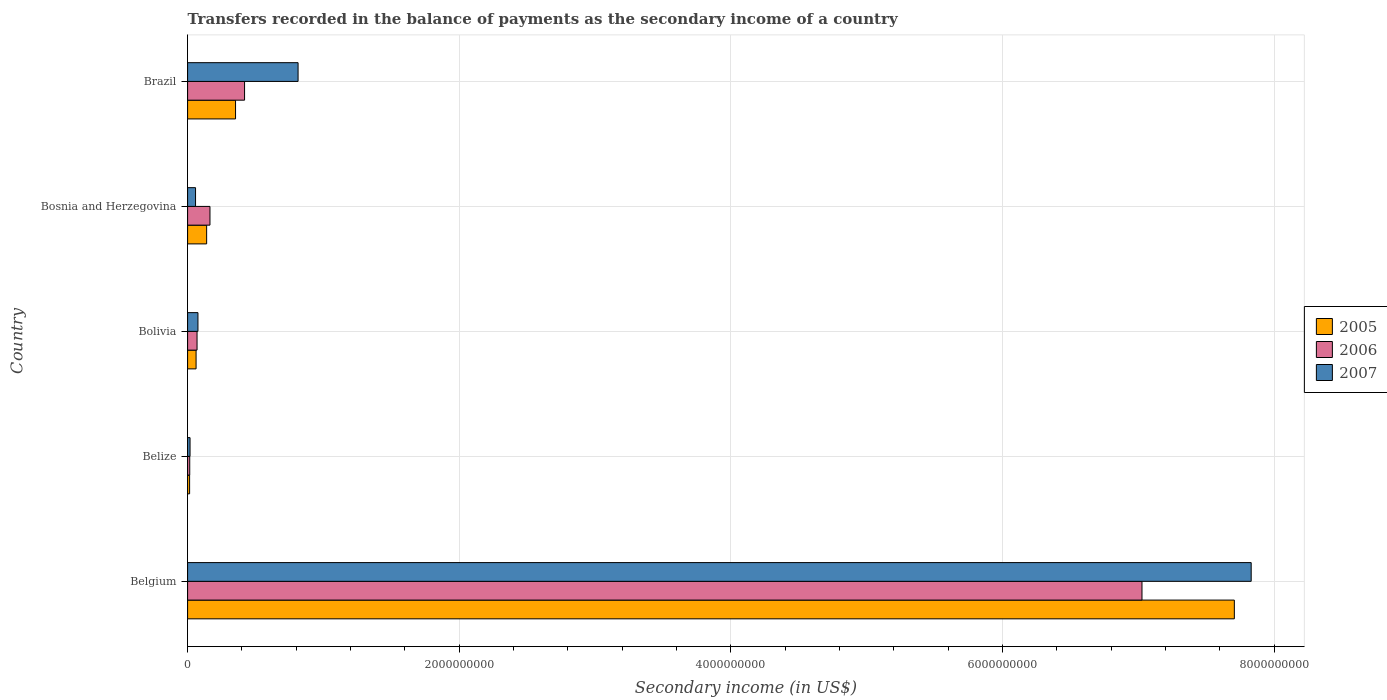How many different coloured bars are there?
Your response must be concise. 3. How many groups of bars are there?
Your answer should be compact. 5. How many bars are there on the 2nd tick from the bottom?
Give a very brief answer. 3. In how many cases, is the number of bars for a given country not equal to the number of legend labels?
Provide a succinct answer. 0. What is the secondary income of in 2006 in Bosnia and Herzegovina?
Your response must be concise. 1.65e+08. Across all countries, what is the maximum secondary income of in 2007?
Provide a succinct answer. 7.83e+09. Across all countries, what is the minimum secondary income of in 2007?
Offer a terse response. 1.80e+07. In which country was the secondary income of in 2006 maximum?
Ensure brevity in your answer.  Belgium. In which country was the secondary income of in 2006 minimum?
Your answer should be very brief. Belize. What is the total secondary income of in 2007 in the graph?
Your answer should be compact. 8.80e+09. What is the difference between the secondary income of in 2006 in Belize and that in Bolivia?
Provide a succinct answer. -5.38e+07. What is the difference between the secondary income of in 2006 in Bolivia and the secondary income of in 2007 in Belgium?
Provide a short and direct response. -7.76e+09. What is the average secondary income of in 2007 per country?
Provide a short and direct response. 1.76e+09. What is the difference between the secondary income of in 2005 and secondary income of in 2006 in Bosnia and Herzegovina?
Offer a very short reply. -2.45e+07. In how many countries, is the secondary income of in 2006 greater than 7200000000 US$?
Your answer should be very brief. 0. What is the ratio of the secondary income of in 2007 in Belize to that in Bosnia and Herzegovina?
Your answer should be very brief. 0.31. What is the difference between the highest and the second highest secondary income of in 2005?
Ensure brevity in your answer.  7.35e+09. What is the difference between the highest and the lowest secondary income of in 2006?
Ensure brevity in your answer.  7.01e+09. What does the 3rd bar from the top in Brazil represents?
Offer a terse response. 2005. Is it the case that in every country, the sum of the secondary income of in 2006 and secondary income of in 2005 is greater than the secondary income of in 2007?
Offer a terse response. No. Are all the bars in the graph horizontal?
Ensure brevity in your answer.  Yes. How many countries are there in the graph?
Offer a terse response. 5. Does the graph contain any zero values?
Give a very brief answer. No. Where does the legend appear in the graph?
Give a very brief answer. Center right. What is the title of the graph?
Provide a short and direct response. Transfers recorded in the balance of payments as the secondary income of a country. Does "1991" appear as one of the legend labels in the graph?
Ensure brevity in your answer.  No. What is the label or title of the X-axis?
Keep it short and to the point. Secondary income (in US$). What is the label or title of the Y-axis?
Ensure brevity in your answer.  Country. What is the Secondary income (in US$) of 2005 in Belgium?
Your answer should be compact. 7.71e+09. What is the Secondary income (in US$) of 2006 in Belgium?
Keep it short and to the point. 7.03e+09. What is the Secondary income (in US$) in 2007 in Belgium?
Offer a very short reply. 7.83e+09. What is the Secondary income (in US$) in 2005 in Belize?
Provide a succinct answer. 1.48e+07. What is the Secondary income (in US$) in 2006 in Belize?
Your answer should be compact. 1.58e+07. What is the Secondary income (in US$) in 2007 in Belize?
Offer a terse response. 1.80e+07. What is the Secondary income (in US$) in 2005 in Bolivia?
Provide a short and direct response. 6.25e+07. What is the Secondary income (in US$) of 2006 in Bolivia?
Your response must be concise. 6.96e+07. What is the Secondary income (in US$) of 2007 in Bolivia?
Your answer should be compact. 7.62e+07. What is the Secondary income (in US$) of 2005 in Bosnia and Herzegovina?
Your answer should be compact. 1.40e+08. What is the Secondary income (in US$) of 2006 in Bosnia and Herzegovina?
Give a very brief answer. 1.65e+08. What is the Secondary income (in US$) in 2007 in Bosnia and Herzegovina?
Give a very brief answer. 5.85e+07. What is the Secondary income (in US$) of 2005 in Brazil?
Give a very brief answer. 3.53e+08. What is the Secondary income (in US$) in 2006 in Brazil?
Your answer should be very brief. 4.19e+08. What is the Secondary income (in US$) in 2007 in Brazil?
Your response must be concise. 8.13e+08. Across all countries, what is the maximum Secondary income (in US$) of 2005?
Provide a succinct answer. 7.71e+09. Across all countries, what is the maximum Secondary income (in US$) in 2006?
Your answer should be compact. 7.03e+09. Across all countries, what is the maximum Secondary income (in US$) of 2007?
Your answer should be compact. 7.83e+09. Across all countries, what is the minimum Secondary income (in US$) of 2005?
Offer a very short reply. 1.48e+07. Across all countries, what is the minimum Secondary income (in US$) in 2006?
Your answer should be very brief. 1.58e+07. Across all countries, what is the minimum Secondary income (in US$) in 2007?
Give a very brief answer. 1.80e+07. What is the total Secondary income (in US$) in 2005 in the graph?
Provide a short and direct response. 8.28e+09. What is the total Secondary income (in US$) of 2006 in the graph?
Your answer should be compact. 7.70e+09. What is the total Secondary income (in US$) of 2007 in the graph?
Provide a succinct answer. 8.80e+09. What is the difference between the Secondary income (in US$) in 2005 in Belgium and that in Belize?
Make the answer very short. 7.69e+09. What is the difference between the Secondary income (in US$) of 2006 in Belgium and that in Belize?
Your answer should be very brief. 7.01e+09. What is the difference between the Secondary income (in US$) of 2007 in Belgium and that in Belize?
Offer a very short reply. 7.81e+09. What is the difference between the Secondary income (in US$) in 2005 in Belgium and that in Bolivia?
Ensure brevity in your answer.  7.64e+09. What is the difference between the Secondary income (in US$) of 2006 in Belgium and that in Bolivia?
Your response must be concise. 6.96e+09. What is the difference between the Secondary income (in US$) of 2007 in Belgium and that in Bolivia?
Your answer should be compact. 7.76e+09. What is the difference between the Secondary income (in US$) in 2005 in Belgium and that in Bosnia and Herzegovina?
Provide a short and direct response. 7.57e+09. What is the difference between the Secondary income (in US$) in 2006 in Belgium and that in Bosnia and Herzegovina?
Your answer should be compact. 6.86e+09. What is the difference between the Secondary income (in US$) of 2007 in Belgium and that in Bosnia and Herzegovina?
Offer a very short reply. 7.77e+09. What is the difference between the Secondary income (in US$) in 2005 in Belgium and that in Brazil?
Offer a terse response. 7.35e+09. What is the difference between the Secondary income (in US$) of 2006 in Belgium and that in Brazil?
Offer a very short reply. 6.61e+09. What is the difference between the Secondary income (in US$) of 2007 in Belgium and that in Brazil?
Provide a succinct answer. 7.02e+09. What is the difference between the Secondary income (in US$) of 2005 in Belize and that in Bolivia?
Keep it short and to the point. -4.77e+07. What is the difference between the Secondary income (in US$) of 2006 in Belize and that in Bolivia?
Keep it short and to the point. -5.38e+07. What is the difference between the Secondary income (in US$) of 2007 in Belize and that in Bolivia?
Your answer should be very brief. -5.82e+07. What is the difference between the Secondary income (in US$) in 2005 in Belize and that in Bosnia and Herzegovina?
Your answer should be compact. -1.25e+08. What is the difference between the Secondary income (in US$) in 2006 in Belize and that in Bosnia and Herzegovina?
Your response must be concise. -1.49e+08. What is the difference between the Secondary income (in US$) of 2007 in Belize and that in Bosnia and Herzegovina?
Make the answer very short. -4.05e+07. What is the difference between the Secondary income (in US$) of 2005 in Belize and that in Brazil?
Your answer should be compact. -3.38e+08. What is the difference between the Secondary income (in US$) of 2006 in Belize and that in Brazil?
Your answer should be very brief. -4.04e+08. What is the difference between the Secondary income (in US$) of 2007 in Belize and that in Brazil?
Offer a terse response. -7.95e+08. What is the difference between the Secondary income (in US$) in 2005 in Bolivia and that in Bosnia and Herzegovina?
Keep it short and to the point. -7.78e+07. What is the difference between the Secondary income (in US$) of 2006 in Bolivia and that in Bosnia and Herzegovina?
Make the answer very short. -9.51e+07. What is the difference between the Secondary income (in US$) in 2007 in Bolivia and that in Bosnia and Herzegovina?
Make the answer very short. 1.77e+07. What is the difference between the Secondary income (in US$) of 2005 in Bolivia and that in Brazil?
Your answer should be very brief. -2.91e+08. What is the difference between the Secondary income (in US$) of 2006 in Bolivia and that in Brazil?
Ensure brevity in your answer.  -3.50e+08. What is the difference between the Secondary income (in US$) in 2007 in Bolivia and that in Brazil?
Your answer should be compact. -7.37e+08. What is the difference between the Secondary income (in US$) in 2005 in Bosnia and Herzegovina and that in Brazil?
Give a very brief answer. -2.13e+08. What is the difference between the Secondary income (in US$) in 2006 in Bosnia and Herzegovina and that in Brazil?
Make the answer very short. -2.55e+08. What is the difference between the Secondary income (in US$) of 2007 in Bosnia and Herzegovina and that in Brazil?
Provide a succinct answer. -7.55e+08. What is the difference between the Secondary income (in US$) in 2005 in Belgium and the Secondary income (in US$) in 2006 in Belize?
Provide a succinct answer. 7.69e+09. What is the difference between the Secondary income (in US$) in 2005 in Belgium and the Secondary income (in US$) in 2007 in Belize?
Offer a terse response. 7.69e+09. What is the difference between the Secondary income (in US$) of 2006 in Belgium and the Secondary income (in US$) of 2007 in Belize?
Give a very brief answer. 7.01e+09. What is the difference between the Secondary income (in US$) of 2005 in Belgium and the Secondary income (in US$) of 2006 in Bolivia?
Your answer should be very brief. 7.64e+09. What is the difference between the Secondary income (in US$) of 2005 in Belgium and the Secondary income (in US$) of 2007 in Bolivia?
Make the answer very short. 7.63e+09. What is the difference between the Secondary income (in US$) of 2006 in Belgium and the Secondary income (in US$) of 2007 in Bolivia?
Offer a very short reply. 6.95e+09. What is the difference between the Secondary income (in US$) in 2005 in Belgium and the Secondary income (in US$) in 2006 in Bosnia and Herzegovina?
Keep it short and to the point. 7.54e+09. What is the difference between the Secondary income (in US$) of 2005 in Belgium and the Secondary income (in US$) of 2007 in Bosnia and Herzegovina?
Your response must be concise. 7.65e+09. What is the difference between the Secondary income (in US$) of 2006 in Belgium and the Secondary income (in US$) of 2007 in Bosnia and Herzegovina?
Give a very brief answer. 6.97e+09. What is the difference between the Secondary income (in US$) of 2005 in Belgium and the Secondary income (in US$) of 2006 in Brazil?
Give a very brief answer. 7.29e+09. What is the difference between the Secondary income (in US$) of 2005 in Belgium and the Secondary income (in US$) of 2007 in Brazil?
Your answer should be very brief. 6.89e+09. What is the difference between the Secondary income (in US$) in 2006 in Belgium and the Secondary income (in US$) in 2007 in Brazil?
Provide a succinct answer. 6.21e+09. What is the difference between the Secondary income (in US$) of 2005 in Belize and the Secondary income (in US$) of 2006 in Bolivia?
Offer a terse response. -5.48e+07. What is the difference between the Secondary income (in US$) in 2005 in Belize and the Secondary income (in US$) in 2007 in Bolivia?
Keep it short and to the point. -6.14e+07. What is the difference between the Secondary income (in US$) of 2006 in Belize and the Secondary income (in US$) of 2007 in Bolivia?
Make the answer very short. -6.05e+07. What is the difference between the Secondary income (in US$) of 2005 in Belize and the Secondary income (in US$) of 2006 in Bosnia and Herzegovina?
Ensure brevity in your answer.  -1.50e+08. What is the difference between the Secondary income (in US$) of 2005 in Belize and the Secondary income (in US$) of 2007 in Bosnia and Herzegovina?
Your answer should be compact. -4.37e+07. What is the difference between the Secondary income (in US$) of 2006 in Belize and the Secondary income (in US$) of 2007 in Bosnia and Herzegovina?
Provide a succinct answer. -4.28e+07. What is the difference between the Secondary income (in US$) of 2005 in Belize and the Secondary income (in US$) of 2006 in Brazil?
Provide a succinct answer. -4.05e+08. What is the difference between the Secondary income (in US$) in 2005 in Belize and the Secondary income (in US$) in 2007 in Brazil?
Make the answer very short. -7.99e+08. What is the difference between the Secondary income (in US$) of 2006 in Belize and the Secondary income (in US$) of 2007 in Brazil?
Provide a short and direct response. -7.98e+08. What is the difference between the Secondary income (in US$) of 2005 in Bolivia and the Secondary income (in US$) of 2006 in Bosnia and Herzegovina?
Ensure brevity in your answer.  -1.02e+08. What is the difference between the Secondary income (in US$) in 2005 in Bolivia and the Secondary income (in US$) in 2007 in Bosnia and Herzegovina?
Your response must be concise. 3.96e+06. What is the difference between the Secondary income (in US$) in 2006 in Bolivia and the Secondary income (in US$) in 2007 in Bosnia and Herzegovina?
Your answer should be compact. 1.11e+07. What is the difference between the Secondary income (in US$) in 2005 in Bolivia and the Secondary income (in US$) in 2006 in Brazil?
Give a very brief answer. -3.57e+08. What is the difference between the Secondary income (in US$) of 2005 in Bolivia and the Secondary income (in US$) of 2007 in Brazil?
Your answer should be very brief. -7.51e+08. What is the difference between the Secondary income (in US$) of 2006 in Bolivia and the Secondary income (in US$) of 2007 in Brazil?
Your answer should be compact. -7.44e+08. What is the difference between the Secondary income (in US$) in 2005 in Bosnia and Herzegovina and the Secondary income (in US$) in 2006 in Brazil?
Keep it short and to the point. -2.79e+08. What is the difference between the Secondary income (in US$) in 2005 in Bosnia and Herzegovina and the Secondary income (in US$) in 2007 in Brazil?
Your answer should be very brief. -6.73e+08. What is the difference between the Secondary income (in US$) in 2006 in Bosnia and Herzegovina and the Secondary income (in US$) in 2007 in Brazil?
Your answer should be compact. -6.49e+08. What is the average Secondary income (in US$) of 2005 per country?
Offer a very short reply. 1.66e+09. What is the average Secondary income (in US$) in 2006 per country?
Offer a terse response. 1.54e+09. What is the average Secondary income (in US$) of 2007 per country?
Your response must be concise. 1.76e+09. What is the difference between the Secondary income (in US$) of 2005 and Secondary income (in US$) of 2006 in Belgium?
Keep it short and to the point. 6.80e+08. What is the difference between the Secondary income (in US$) in 2005 and Secondary income (in US$) in 2007 in Belgium?
Offer a terse response. -1.24e+08. What is the difference between the Secondary income (in US$) of 2006 and Secondary income (in US$) of 2007 in Belgium?
Ensure brevity in your answer.  -8.04e+08. What is the difference between the Secondary income (in US$) in 2005 and Secondary income (in US$) in 2006 in Belize?
Offer a very short reply. -9.82e+05. What is the difference between the Secondary income (in US$) of 2005 and Secondary income (in US$) of 2007 in Belize?
Keep it short and to the point. -3.23e+06. What is the difference between the Secondary income (in US$) of 2006 and Secondary income (in US$) of 2007 in Belize?
Give a very brief answer. -2.25e+06. What is the difference between the Secondary income (in US$) of 2005 and Secondary income (in US$) of 2006 in Bolivia?
Your answer should be compact. -7.13e+06. What is the difference between the Secondary income (in US$) of 2005 and Secondary income (in US$) of 2007 in Bolivia?
Your answer should be very brief. -1.38e+07. What is the difference between the Secondary income (in US$) in 2006 and Secondary income (in US$) in 2007 in Bolivia?
Make the answer very short. -6.62e+06. What is the difference between the Secondary income (in US$) in 2005 and Secondary income (in US$) in 2006 in Bosnia and Herzegovina?
Provide a short and direct response. -2.45e+07. What is the difference between the Secondary income (in US$) in 2005 and Secondary income (in US$) in 2007 in Bosnia and Herzegovina?
Give a very brief answer. 8.17e+07. What is the difference between the Secondary income (in US$) in 2006 and Secondary income (in US$) in 2007 in Bosnia and Herzegovina?
Provide a short and direct response. 1.06e+08. What is the difference between the Secondary income (in US$) in 2005 and Secondary income (in US$) in 2006 in Brazil?
Offer a very short reply. -6.63e+07. What is the difference between the Secondary income (in US$) in 2005 and Secondary income (in US$) in 2007 in Brazil?
Ensure brevity in your answer.  -4.60e+08. What is the difference between the Secondary income (in US$) of 2006 and Secondary income (in US$) of 2007 in Brazil?
Ensure brevity in your answer.  -3.94e+08. What is the ratio of the Secondary income (in US$) of 2005 in Belgium to that in Belize?
Keep it short and to the point. 521.84. What is the ratio of the Secondary income (in US$) in 2006 in Belgium to that in Belize?
Provide a short and direct response. 446.15. What is the ratio of the Secondary income (in US$) of 2007 in Belgium to that in Belize?
Give a very brief answer. 435.15. What is the ratio of the Secondary income (in US$) of 2005 in Belgium to that in Bolivia?
Your answer should be very brief. 123.39. What is the ratio of the Secondary income (in US$) of 2006 in Belgium to that in Bolivia?
Your answer should be compact. 100.97. What is the ratio of the Secondary income (in US$) of 2007 in Belgium to that in Bolivia?
Provide a short and direct response. 102.75. What is the ratio of the Secondary income (in US$) of 2005 in Belgium to that in Bosnia and Herzegovina?
Make the answer very short. 54.95. What is the ratio of the Secondary income (in US$) of 2006 in Belgium to that in Bosnia and Herzegovina?
Your answer should be very brief. 42.66. What is the ratio of the Secondary income (in US$) of 2007 in Belgium to that in Bosnia and Herzegovina?
Your answer should be compact. 133.85. What is the ratio of the Secondary income (in US$) in 2005 in Belgium to that in Brazil?
Keep it short and to the point. 21.83. What is the ratio of the Secondary income (in US$) in 2006 in Belgium to that in Brazil?
Offer a very short reply. 16.76. What is the ratio of the Secondary income (in US$) of 2007 in Belgium to that in Brazil?
Ensure brevity in your answer.  9.63. What is the ratio of the Secondary income (in US$) of 2005 in Belize to that in Bolivia?
Your answer should be compact. 0.24. What is the ratio of the Secondary income (in US$) of 2006 in Belize to that in Bolivia?
Give a very brief answer. 0.23. What is the ratio of the Secondary income (in US$) in 2007 in Belize to that in Bolivia?
Provide a succinct answer. 0.24. What is the ratio of the Secondary income (in US$) in 2005 in Belize to that in Bosnia and Herzegovina?
Offer a very short reply. 0.11. What is the ratio of the Secondary income (in US$) in 2006 in Belize to that in Bosnia and Herzegovina?
Make the answer very short. 0.1. What is the ratio of the Secondary income (in US$) in 2007 in Belize to that in Bosnia and Herzegovina?
Offer a terse response. 0.31. What is the ratio of the Secondary income (in US$) of 2005 in Belize to that in Brazil?
Offer a very short reply. 0.04. What is the ratio of the Secondary income (in US$) in 2006 in Belize to that in Brazil?
Your answer should be very brief. 0.04. What is the ratio of the Secondary income (in US$) in 2007 in Belize to that in Brazil?
Your response must be concise. 0.02. What is the ratio of the Secondary income (in US$) in 2005 in Bolivia to that in Bosnia and Herzegovina?
Provide a succinct answer. 0.45. What is the ratio of the Secondary income (in US$) of 2006 in Bolivia to that in Bosnia and Herzegovina?
Offer a terse response. 0.42. What is the ratio of the Secondary income (in US$) in 2007 in Bolivia to that in Bosnia and Herzegovina?
Your answer should be very brief. 1.3. What is the ratio of the Secondary income (in US$) in 2005 in Bolivia to that in Brazil?
Provide a short and direct response. 0.18. What is the ratio of the Secondary income (in US$) in 2006 in Bolivia to that in Brazil?
Offer a very short reply. 0.17. What is the ratio of the Secondary income (in US$) of 2007 in Bolivia to that in Brazil?
Keep it short and to the point. 0.09. What is the ratio of the Secondary income (in US$) of 2005 in Bosnia and Herzegovina to that in Brazil?
Give a very brief answer. 0.4. What is the ratio of the Secondary income (in US$) in 2006 in Bosnia and Herzegovina to that in Brazil?
Ensure brevity in your answer.  0.39. What is the ratio of the Secondary income (in US$) in 2007 in Bosnia and Herzegovina to that in Brazil?
Give a very brief answer. 0.07. What is the difference between the highest and the second highest Secondary income (in US$) in 2005?
Your response must be concise. 7.35e+09. What is the difference between the highest and the second highest Secondary income (in US$) in 2006?
Provide a succinct answer. 6.61e+09. What is the difference between the highest and the second highest Secondary income (in US$) in 2007?
Give a very brief answer. 7.02e+09. What is the difference between the highest and the lowest Secondary income (in US$) in 2005?
Offer a very short reply. 7.69e+09. What is the difference between the highest and the lowest Secondary income (in US$) of 2006?
Your answer should be very brief. 7.01e+09. What is the difference between the highest and the lowest Secondary income (in US$) in 2007?
Provide a short and direct response. 7.81e+09. 